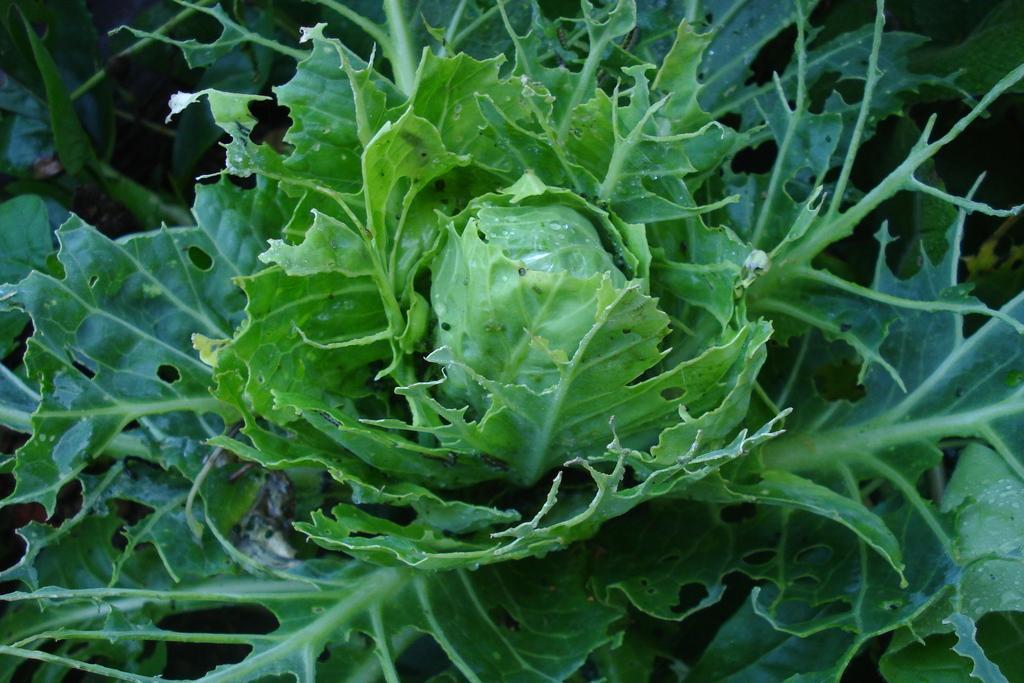Please provide a concise description of this image. In this image we can see a plant. 